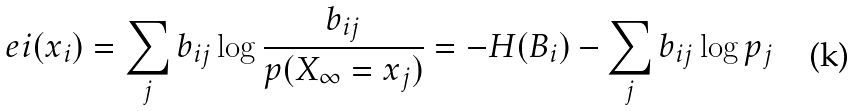<formula> <loc_0><loc_0><loc_500><loc_500>e i ( x _ { i } ) = \sum _ { j } { b _ { i j } \log { \frac { b _ { i j } } { p ( X _ { \infty } = x _ { j } ) } } } = - H ( B _ { i } ) - \sum _ { j } { b _ { i j } \log { p _ { j } } }</formula> 